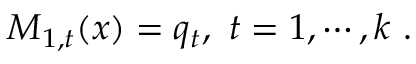Convert formula to latex. <formula><loc_0><loc_0><loc_500><loc_500>M _ { 1 , t } ( x ) = q _ { t } , t = 1 , \cdots , k .</formula> 